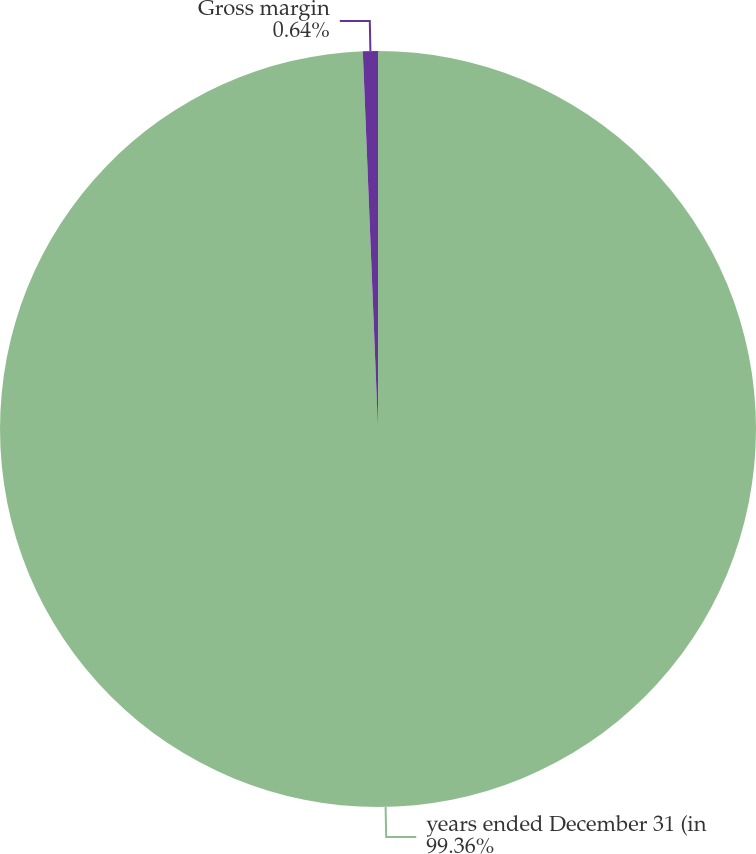<chart> <loc_0><loc_0><loc_500><loc_500><pie_chart><fcel>years ended December 31 (in<fcel>Gross margin<nl><fcel>99.36%<fcel>0.64%<nl></chart> 